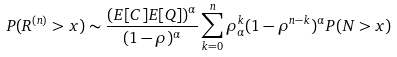Convert formula to latex. <formula><loc_0><loc_0><loc_500><loc_500>P ( R ^ { ( n ) } > x ) \sim \frac { ( E [ C ] E [ Q ] ) ^ { \alpha } } { ( 1 - \rho ) ^ { \alpha } } \sum _ { k = 0 } ^ { n } \rho _ { \alpha } ^ { k } ( 1 - \rho ^ { n - k } ) ^ { \alpha } P ( N > x )</formula> 